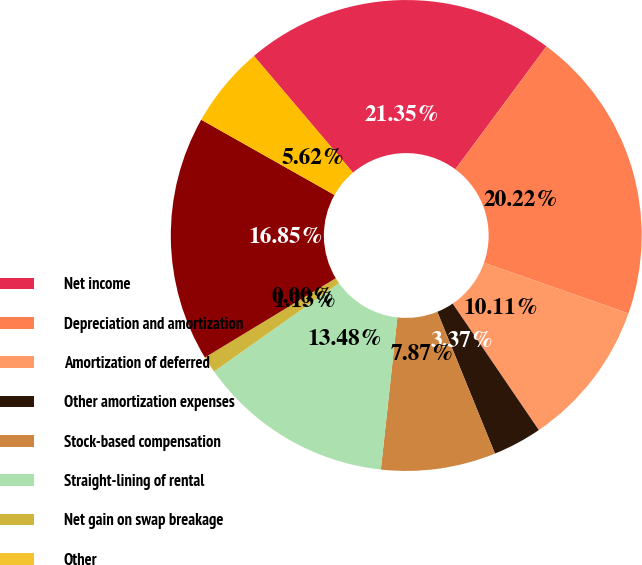Convert chart. <chart><loc_0><loc_0><loc_500><loc_500><pie_chart><fcel>Net income<fcel>Depreciation and amortization<fcel>Amortization of deferred<fcel>Other amortization expenses<fcel>Stock-based compensation<fcel>Straight-lining of rental<fcel>Net gain on swap breakage<fcel>Other<fcel>Decrease (increase) in escrow<fcel>Decrease (increase) in other<nl><fcel>21.35%<fcel>20.22%<fcel>10.11%<fcel>3.37%<fcel>7.87%<fcel>13.48%<fcel>1.13%<fcel>0.0%<fcel>16.85%<fcel>5.62%<nl></chart> 